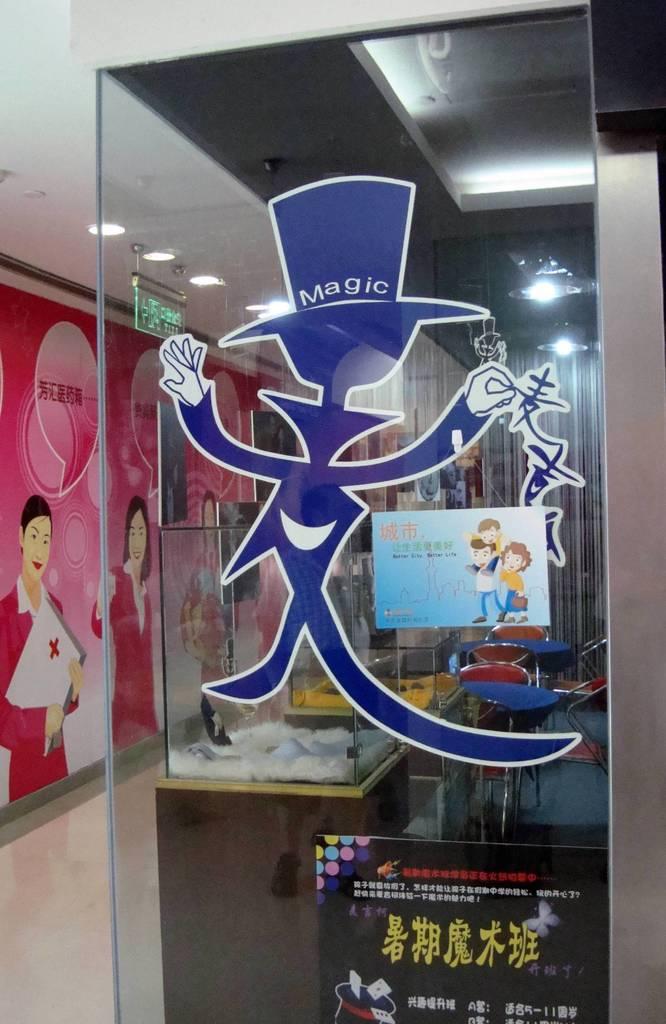What does the man on the window hat say?
Provide a short and direct response. Magic. 